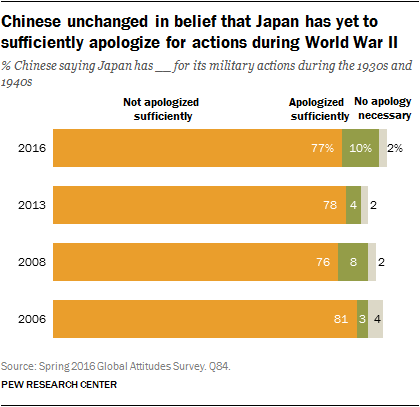Point out several critical features in this image. There are three colors represented in the bar. The average value of all yellow in the chart is 78. 